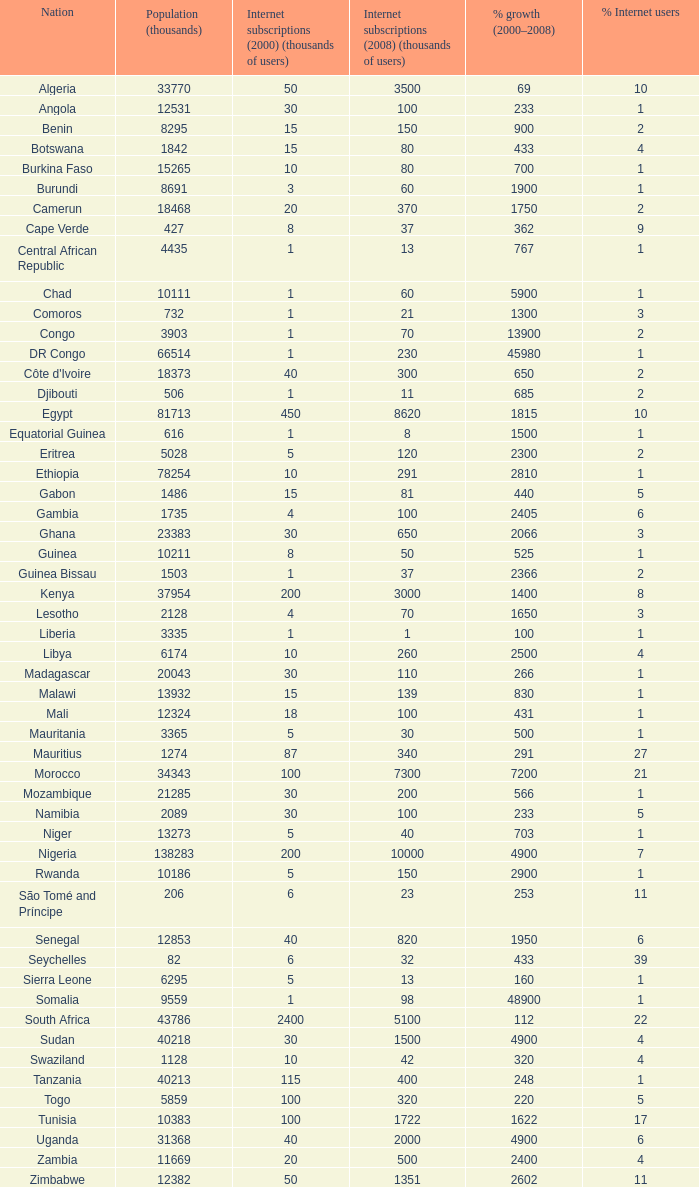Can you provide the combined percentage growth for uganda during the 2000-2008 period? 1.0. 